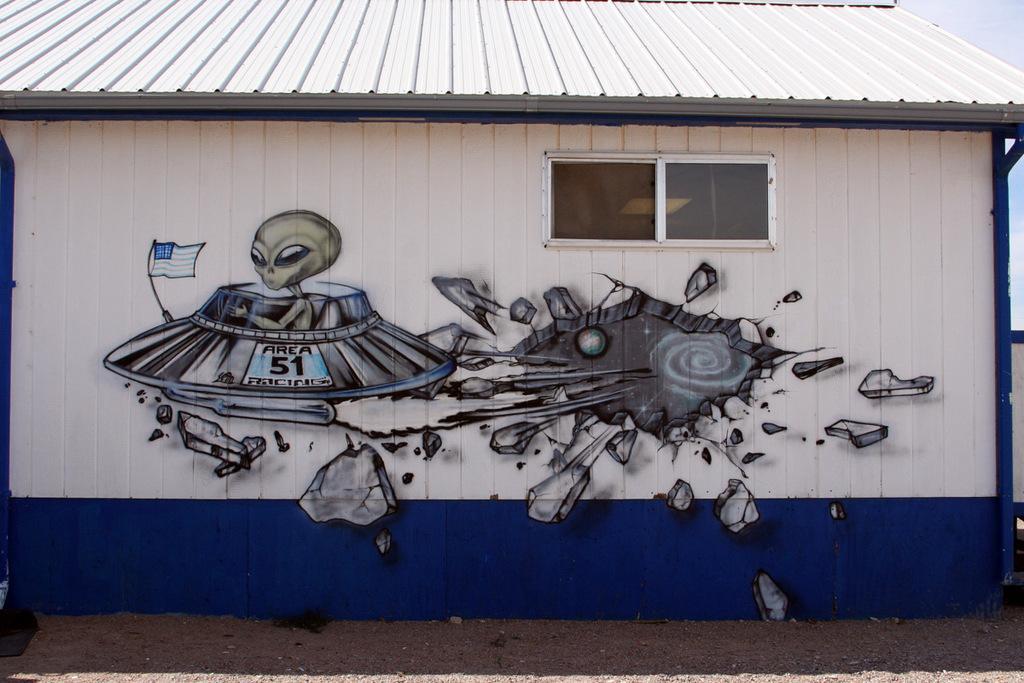Can you describe this image briefly? In this image there is graffiti on the wall of the house, and at the background there is sky. 